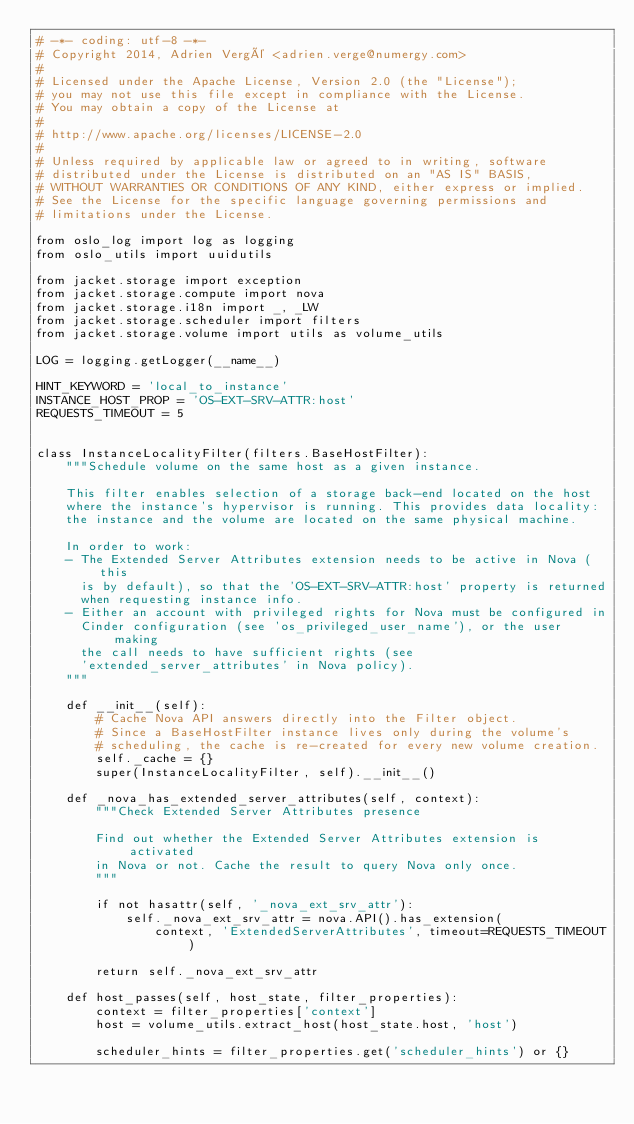<code> <loc_0><loc_0><loc_500><loc_500><_Python_># -*- coding: utf-8 -*-
# Copyright 2014, Adrien Vergé <adrien.verge@numergy.com>
#
# Licensed under the Apache License, Version 2.0 (the "License");
# you may not use this file except in compliance with the License.
# You may obtain a copy of the License at
#
# http://www.apache.org/licenses/LICENSE-2.0
#
# Unless required by applicable law or agreed to in writing, software
# distributed under the License is distributed on an "AS IS" BASIS,
# WITHOUT WARRANTIES OR CONDITIONS OF ANY KIND, either express or implied.
# See the License for the specific language governing permissions and
# limitations under the License.

from oslo_log import log as logging
from oslo_utils import uuidutils

from jacket.storage import exception
from jacket.storage.compute import nova
from jacket.storage.i18n import _, _LW
from jacket.storage.scheduler import filters
from jacket.storage.volume import utils as volume_utils

LOG = logging.getLogger(__name__)

HINT_KEYWORD = 'local_to_instance'
INSTANCE_HOST_PROP = 'OS-EXT-SRV-ATTR:host'
REQUESTS_TIMEOUT = 5


class InstanceLocalityFilter(filters.BaseHostFilter):
    """Schedule volume on the same host as a given instance.

    This filter enables selection of a storage back-end located on the host
    where the instance's hypervisor is running. This provides data locality:
    the instance and the volume are located on the same physical machine.

    In order to work:
    - The Extended Server Attributes extension needs to be active in Nova (this
      is by default), so that the 'OS-EXT-SRV-ATTR:host' property is returned
      when requesting instance info.
    - Either an account with privileged rights for Nova must be configured in
      Cinder configuration (see 'os_privileged_user_name'), or the user making
      the call needs to have sufficient rights (see
      'extended_server_attributes' in Nova policy).
    """

    def __init__(self):
        # Cache Nova API answers directly into the Filter object.
        # Since a BaseHostFilter instance lives only during the volume's
        # scheduling, the cache is re-created for every new volume creation.
        self._cache = {}
        super(InstanceLocalityFilter, self).__init__()

    def _nova_has_extended_server_attributes(self, context):
        """Check Extended Server Attributes presence

        Find out whether the Extended Server Attributes extension is activated
        in Nova or not. Cache the result to query Nova only once.
        """

        if not hasattr(self, '_nova_ext_srv_attr'):
            self._nova_ext_srv_attr = nova.API().has_extension(
                context, 'ExtendedServerAttributes', timeout=REQUESTS_TIMEOUT)

        return self._nova_ext_srv_attr

    def host_passes(self, host_state, filter_properties):
        context = filter_properties['context']
        host = volume_utils.extract_host(host_state.host, 'host')

        scheduler_hints = filter_properties.get('scheduler_hints') or {}</code> 